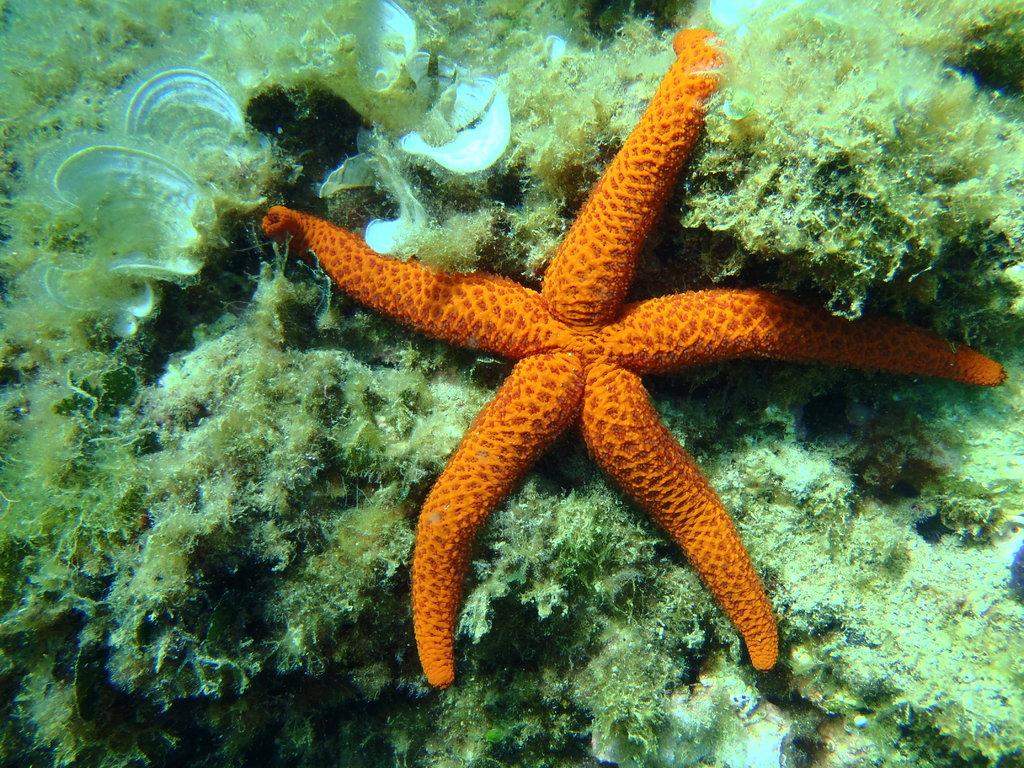What type of marine animal is in the image? There is a starfish in the image. What type of underwater habitat is visible in the image? There is a coral reef in the image. Are the starfish and coral reef in the same environment in the image? Yes, both the starfish and the coral reef are in the water in the image. What rhythm is the porter using to carry the suitcases in the image? There is no porter carrying suitcases in the image; it features a starfish and a coral reef in the water. What arithmetic problem can be solved using the number of starfish in the image? There is only one starfish in the image, so it cannot be used to solve any arithmetic problems. 